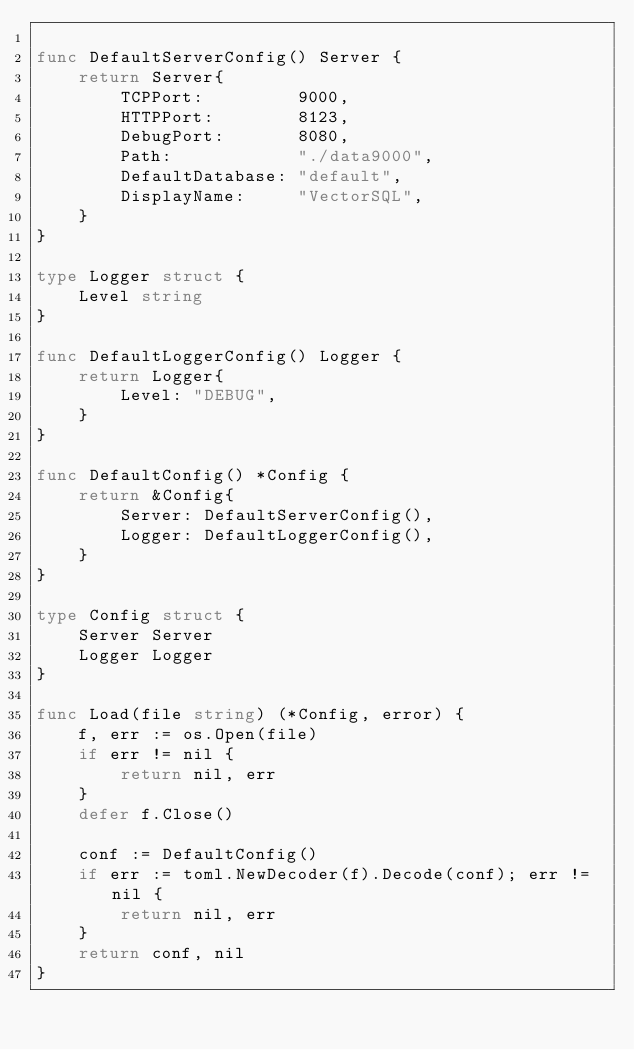<code> <loc_0><loc_0><loc_500><loc_500><_Go_>
func DefaultServerConfig() Server {
	return Server{
		TCPPort:         9000,
		HTTPPort:        8123,
		DebugPort:       8080,
		Path:            "./data9000",
		DefaultDatabase: "default",
		DisplayName:     "VectorSQL",
	}
}

type Logger struct {
	Level string
}

func DefaultLoggerConfig() Logger {
	return Logger{
		Level: "DEBUG",
	}
}

func DefaultConfig() *Config {
	return &Config{
		Server: DefaultServerConfig(),
		Logger: DefaultLoggerConfig(),
	}
}

type Config struct {
	Server Server
	Logger Logger
}

func Load(file string) (*Config, error) {
	f, err := os.Open(file)
	if err != nil {
		return nil, err
	}
	defer f.Close()

	conf := DefaultConfig()
	if err := toml.NewDecoder(f).Decode(conf); err != nil {
		return nil, err
	}
	return conf, nil
}
</code> 